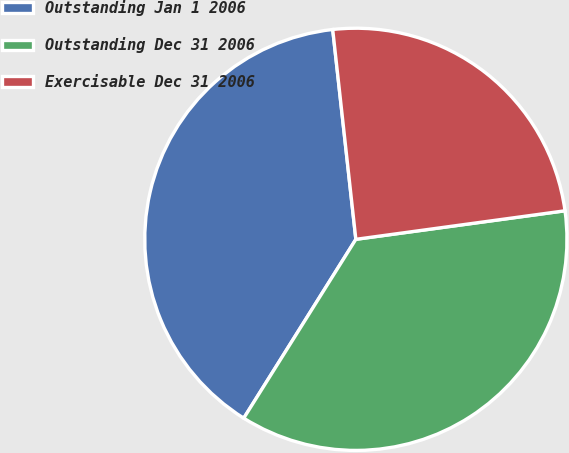Convert chart to OTSL. <chart><loc_0><loc_0><loc_500><loc_500><pie_chart><fcel>Outstanding Jan 1 2006<fcel>Outstanding Dec 31 2006<fcel>Exercisable Dec 31 2006<nl><fcel>39.34%<fcel>36.07%<fcel>24.59%<nl></chart> 